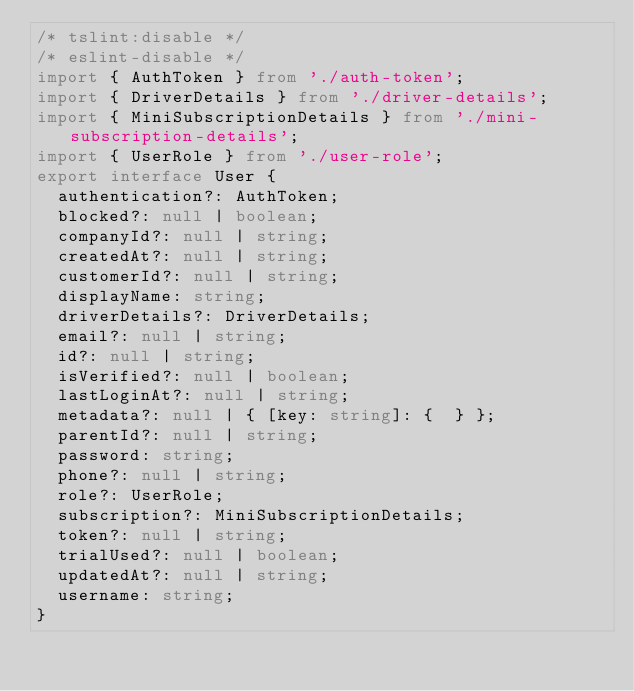Convert code to text. <code><loc_0><loc_0><loc_500><loc_500><_TypeScript_>/* tslint:disable */
/* eslint-disable */
import { AuthToken } from './auth-token';
import { DriverDetails } from './driver-details';
import { MiniSubscriptionDetails } from './mini-subscription-details';
import { UserRole } from './user-role';
export interface User {
  authentication?: AuthToken;
  blocked?: null | boolean;
  companyId?: null | string;
  createdAt?: null | string;
  customerId?: null | string;
  displayName: string;
  driverDetails?: DriverDetails;
  email?: null | string;
  id?: null | string;
  isVerified?: null | boolean;
  lastLoginAt?: null | string;
  metadata?: null | { [key: string]: {  } };
  parentId?: null | string;
  password: string;
  phone?: null | string;
  role?: UserRole;
  subscription?: MiniSubscriptionDetails;
  token?: null | string;
  trialUsed?: null | boolean;
  updatedAt?: null | string;
  username: string;
}
</code> 